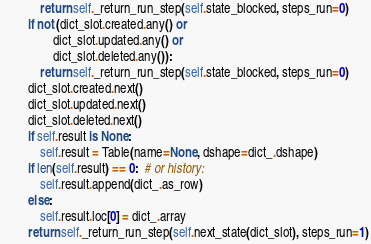Convert code to text. <code><loc_0><loc_0><loc_500><loc_500><_Python_>            return self._return_run_step(self.state_blocked, steps_run=0)
        if not (dict_slot.created.any() or
                dict_slot.updated.any() or
                dict_slot.deleted.any()):
            return self._return_run_step(self.state_blocked, steps_run=0)
        dict_slot.created.next()
        dict_slot.updated.next()
        dict_slot.deleted.next()
        if self.result is None:
            self.result = Table(name=None, dshape=dict_.dshape)
        if len(self.result) == 0:  # or history:
            self.result.append(dict_.as_row)
        else:
            self.result.loc[0] = dict_.array
        return self._return_run_step(self.next_state(dict_slot), steps_run=1)
</code> 